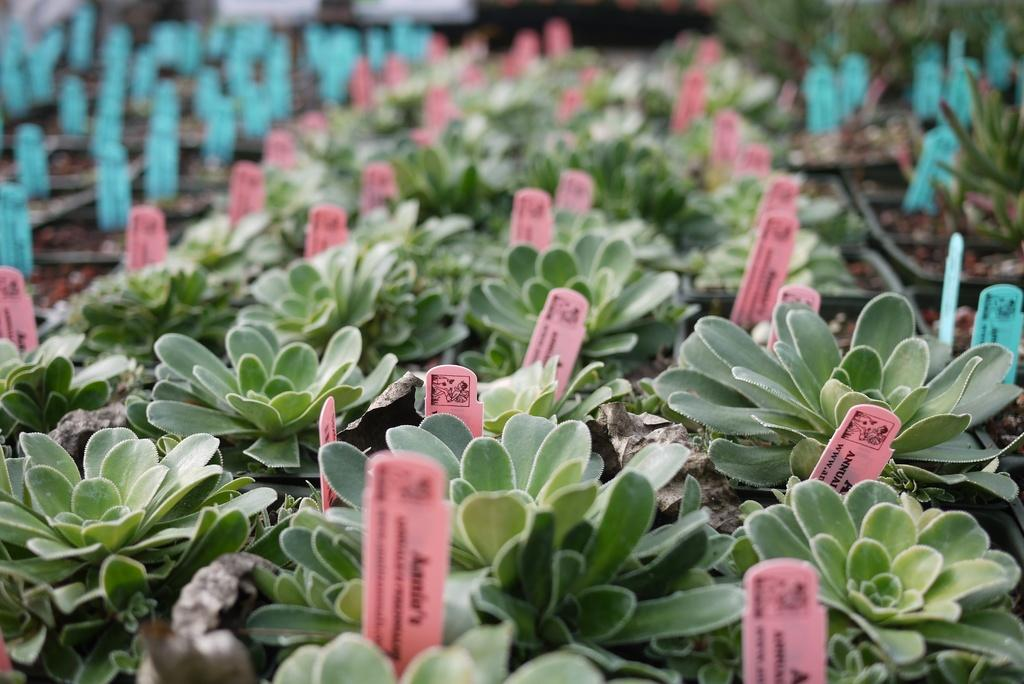What type of living organisms can be seen in the image? Plants can be seen in the image. What are the tags used for in the image? The purpose of the tags in the image is not specified, but they are likely used for identification or labeling. Can you touch the can in the image? There is no can present in the image, so it cannot be touched. 